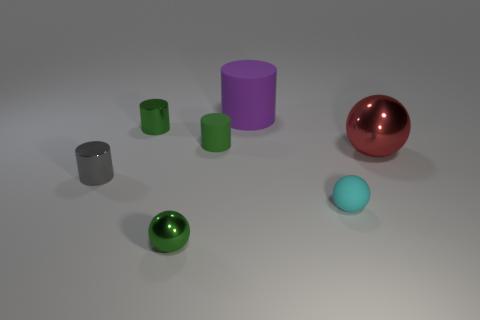What is the shape of the metal thing that is the same color as the tiny metal sphere?
Your answer should be compact. Cylinder. What number of large purple objects are there?
Offer a very short reply. 1. What number of spheres are either tiny objects or matte things?
Your answer should be very brief. 2. The cylinder that is the same size as the red shiny sphere is what color?
Make the answer very short. Purple. How many things are left of the small cyan rubber thing and in front of the large red ball?
Keep it short and to the point. 2. What material is the red sphere?
Your answer should be compact. Metal. What number of objects are either small objects or green spheres?
Keep it short and to the point. 5. Is the size of the object to the right of the tiny matte sphere the same as the shiny sphere left of the red ball?
Your answer should be very brief. No. How many other objects are there of the same size as the gray metal object?
Give a very brief answer. 4. How many objects are either metal cylinders in front of the big red metallic thing or cylinders in front of the big cylinder?
Your answer should be compact. 3. 